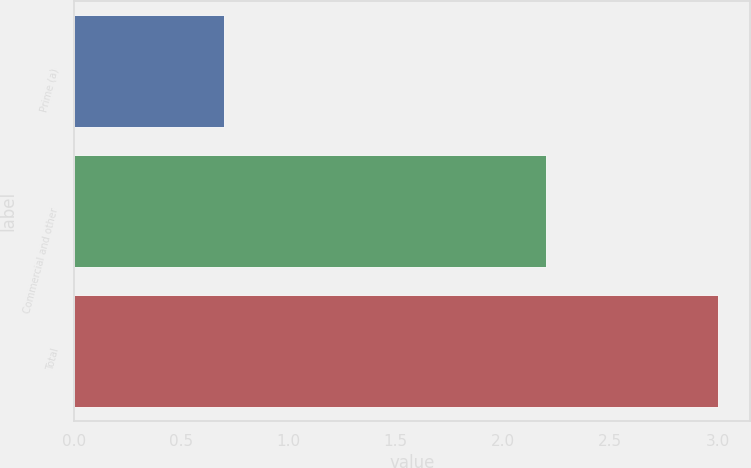<chart> <loc_0><loc_0><loc_500><loc_500><bar_chart><fcel>Prime (a)<fcel>Commercial and other<fcel>Total<nl><fcel>0.7<fcel>2.2<fcel>3<nl></chart> 